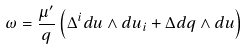<formula> <loc_0><loc_0><loc_500><loc_500>\omega = \frac { \mu ^ { \prime } } { q } \left ( \Delta ^ { i } d u \wedge d u _ { i } + \Delta d q \wedge d u \right )</formula> 